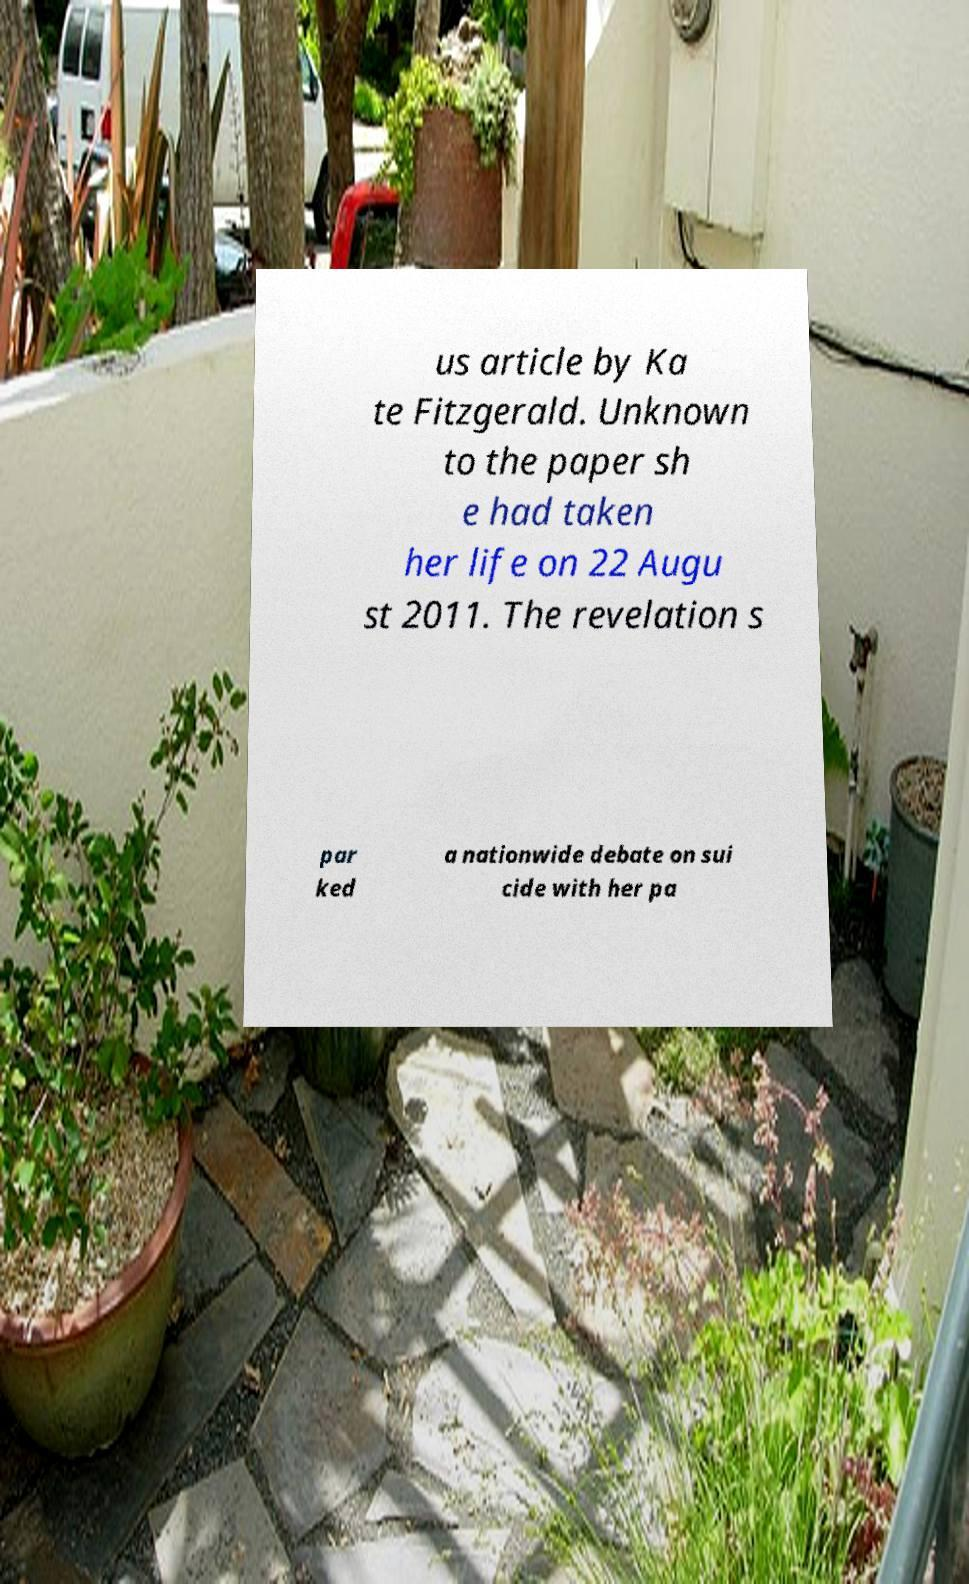Please identify and transcribe the text found in this image. us article by Ka te Fitzgerald. Unknown to the paper sh e had taken her life on 22 Augu st 2011. The revelation s par ked a nationwide debate on sui cide with her pa 